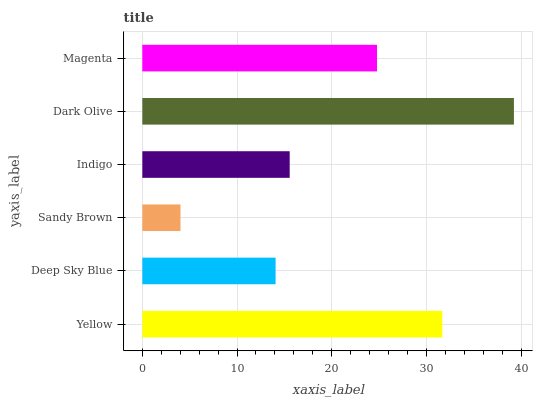Is Sandy Brown the minimum?
Answer yes or no. Yes. Is Dark Olive the maximum?
Answer yes or no. Yes. Is Deep Sky Blue the minimum?
Answer yes or no. No. Is Deep Sky Blue the maximum?
Answer yes or no. No. Is Yellow greater than Deep Sky Blue?
Answer yes or no. Yes. Is Deep Sky Blue less than Yellow?
Answer yes or no. Yes. Is Deep Sky Blue greater than Yellow?
Answer yes or no. No. Is Yellow less than Deep Sky Blue?
Answer yes or no. No. Is Magenta the high median?
Answer yes or no. Yes. Is Indigo the low median?
Answer yes or no. Yes. Is Yellow the high median?
Answer yes or no. No. Is Deep Sky Blue the low median?
Answer yes or no. No. 